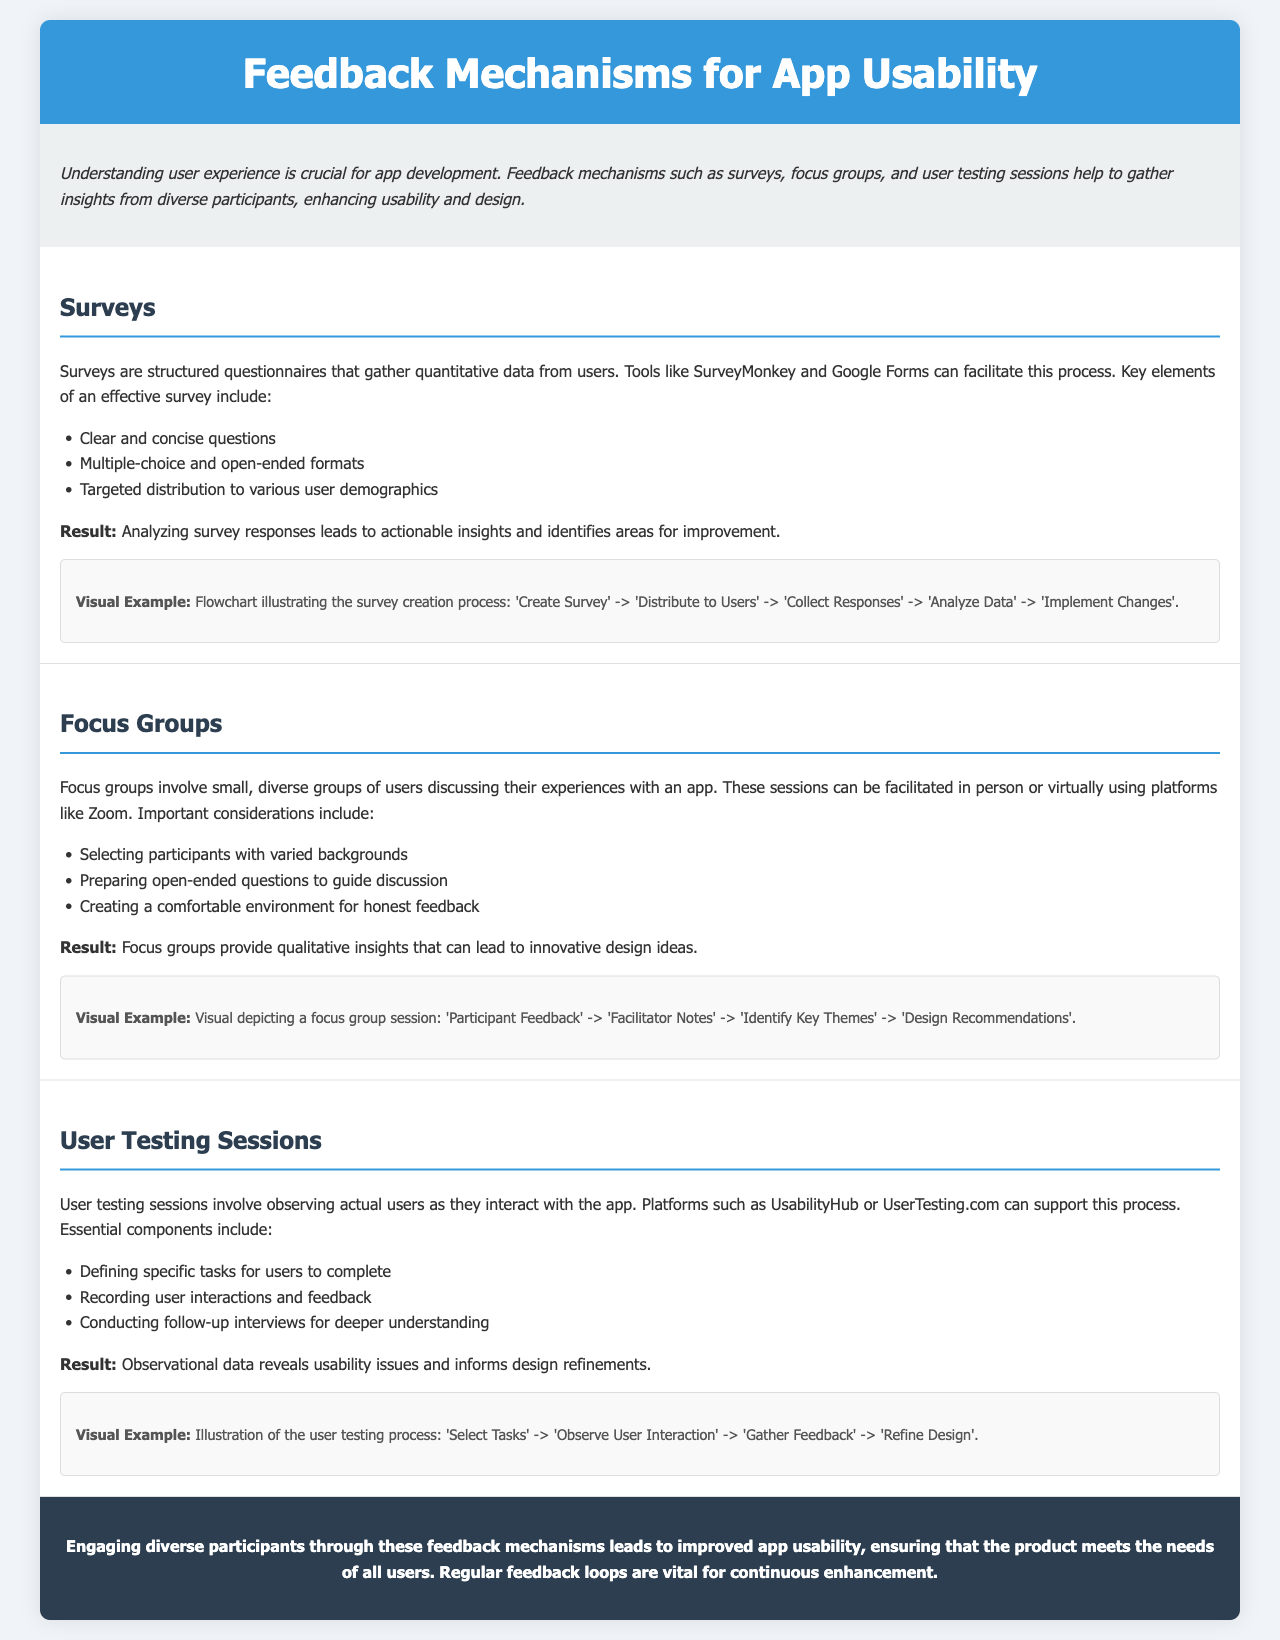What is the title of the document? The title is prominently displayed in the header section of the brochure.
Answer: Feedback Mechanisms for App Usability What are three feedback methods mentioned in the document? The methods are listed under various sections and are clearly defined.
Answer: Surveys, Focus Groups, User Testing Sessions Which tool is mentioned for creating surveys? The document specifies tools that can facilitate survey creation within the content.
Answer: SurveyMonkey What is one key element of an effective survey? The document outlines important elements in bullet points for clarity.
Answer: Clear and concise questions What relationship is illustrated in the surveys visual example? The flowchart shows the process of collecting and analyzing survey responses leading to changes.
Answer: Create Survey -> Distribute to Users -> Collect Responses -> Analyze Data -> Implement Changes What provides qualitative insights in usability testing? The reasoning stems from the description of focus groups and their outcomes in the document.
Answer: Focus Groups What platform can be used for user testing? The document lists tools to support user testing processes, making it easy to identify them.
Answer: UserTesting.com What is the main goal of engaging diverse participants? The conclusion summarizes the purpose of participant engagement in usability feedback.
Answer: Improved app usability How does user testing reveal usability issues? The document states observational data reveals issues, requiring synthesis of information from user testing.
Answer: Observational data 